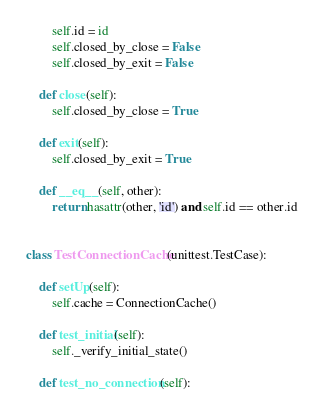<code> <loc_0><loc_0><loc_500><loc_500><_Python_>        self.id = id
        self.closed_by_close = False
        self.closed_by_exit = False

    def close(self):
        self.closed_by_close = True

    def exit(self):
        self.closed_by_exit = True

    def __eq__(self, other):
        return hasattr(other, 'id') and self.id == other.id


class TestConnectionCache(unittest.TestCase):

    def setUp(self):
        self.cache = ConnectionCache()

    def test_initial(self):
        self._verify_initial_state()

    def test_no_connection(self):</code> 